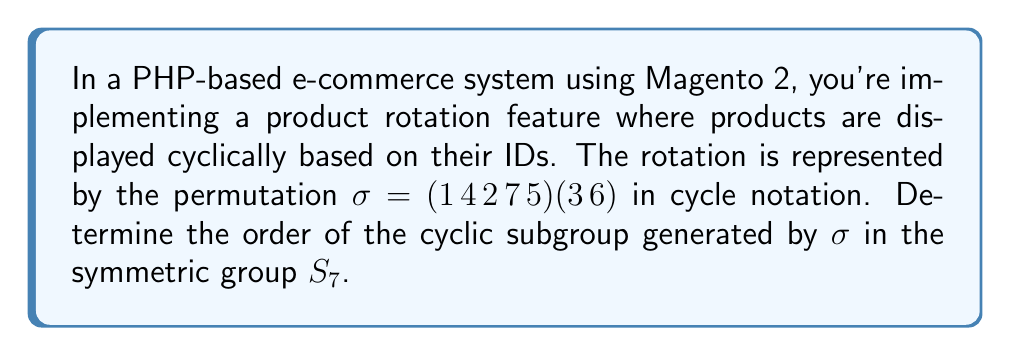Help me with this question. To find the order of the cyclic subgroup generated by $\sigma$, we need to determine the least common multiple (LCM) of the cycle lengths in the permutation. This is because the order of a permutation is the LCM of its cycle lengths.

Step 1: Identify the cycle lengths
- First cycle: $(1\,4\,2\,7\,5)$ has length 5
- Second cycle: $(3\,6)$ has length 2
- The element 7 is fixed (implicitly in a cycle of length 1)

Step 2: Calculate the LCM of the cycle lengths
$LCM(5, 2, 1) = 10$

To verify:
- $\sigma^1 = (1\,4\,2\,7\,5)(3\,6)$
- $\sigma^2 = (1\,2\,5\,4\,7)(3\,6)$
- $\sigma^5 = (3\,6)$
- $\sigma^{10} = (1)(2)(3)(4)(5)(6)(7) = e$ (identity permutation)

Therefore, the order of the cyclic subgroup generated by $\sigma$ is 10.

In the context of the e-commerce system, this means that the product rotation will return to its initial state after 10 applications of the permutation.
Answer: 10 